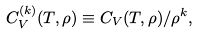<formula> <loc_0><loc_0><loc_500><loc_500>C _ { V } ^ { ( k ) } ( T , \rho ) \equiv C _ { V } ( T , \rho ) / \rho ^ { k } ,</formula> 